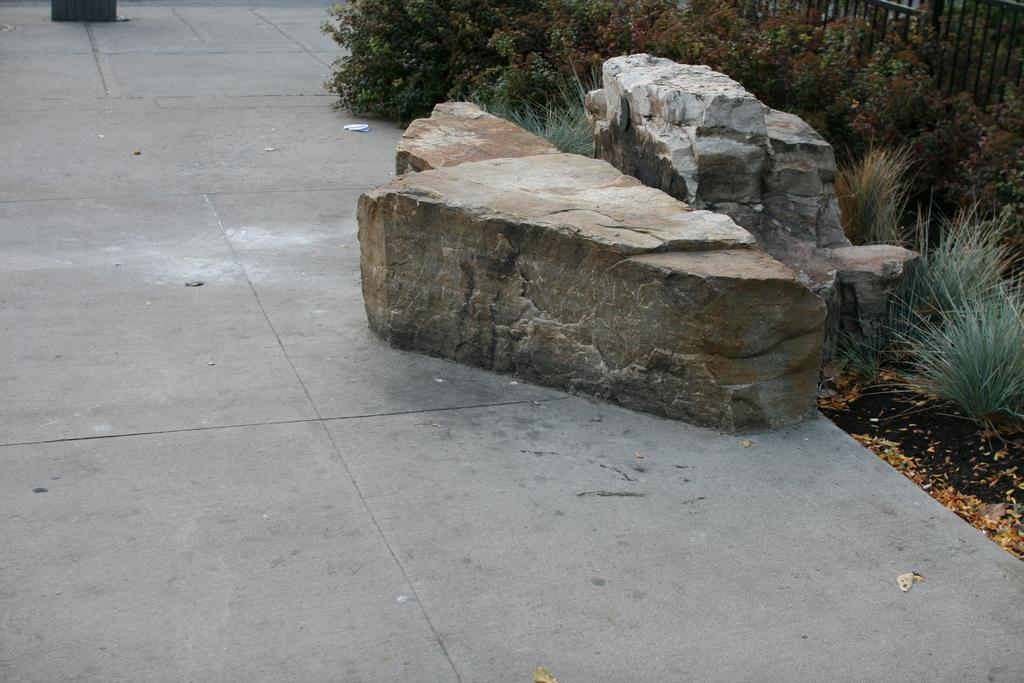What type of vegetation is on the right side of the image? There are plants on the right side of the image. What objects can be seen in the middle of the image? There are two rocks in the middle of the image. What additional details can be observed at the right bottom of the image? There are some leaves at the right bottom of the image. What type of doll can be seen playing with a bar of soap in the image? There is no doll or soap present in the image; it features plants, rocks, and leaves. What color is the cord hanging from the tree in the image? There is no cord hanging from a tree in the image; it only contains plants, rocks, and leaves. 